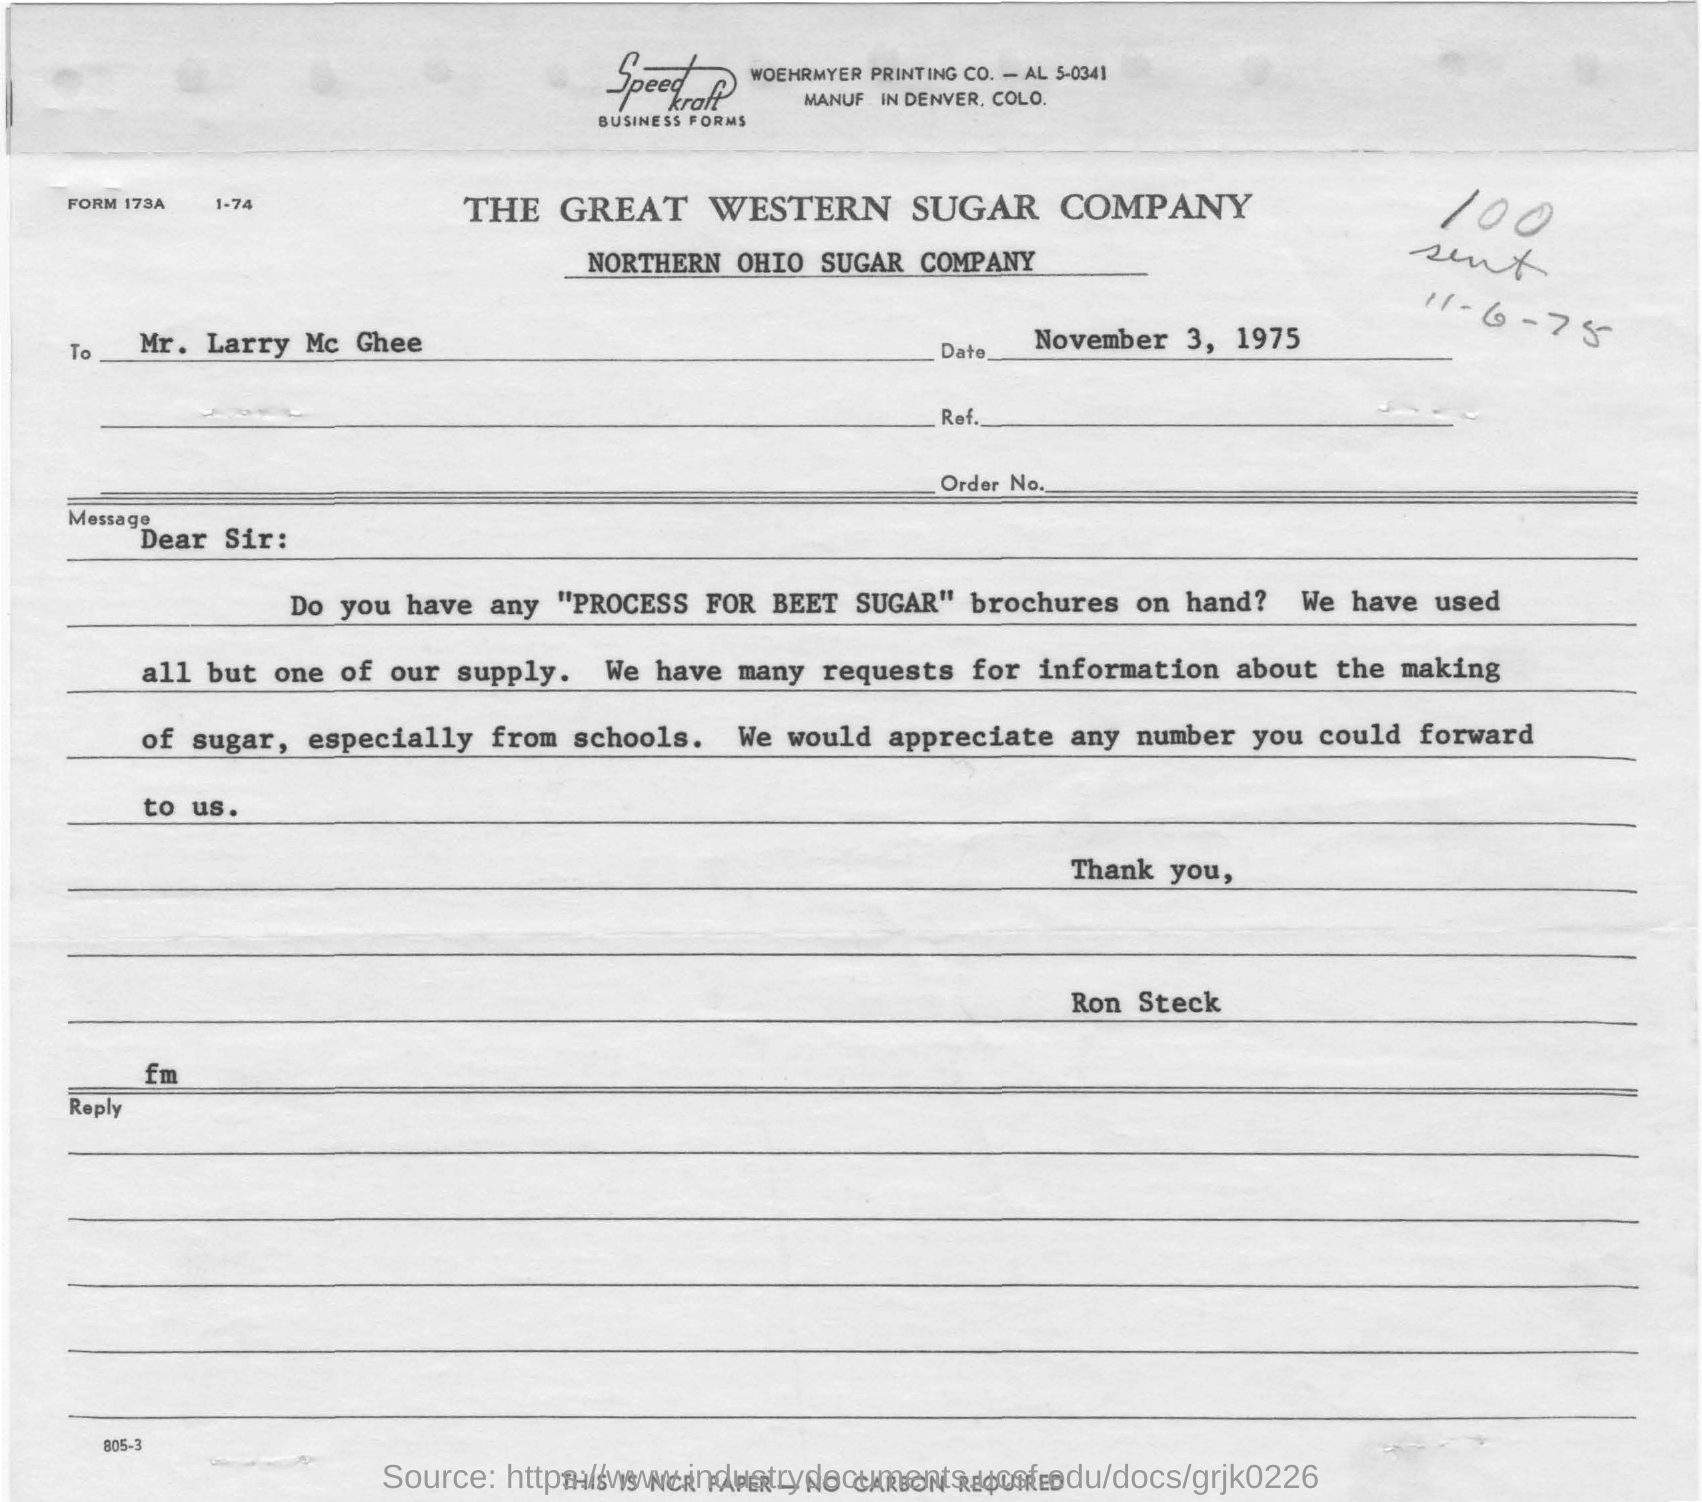Can you infer why the company is specifically receiving requests from schools, as opposed to other organizations or individuals? Schools often seek educational materials to incorporate into their teaching plans, particularly for subjects like science and social studies. Brochures like 'PROCESS FOR BEET SUGAR' provide a practical example of real-world applications of scientific concepts. This hands-on, process-focused information can be an invaluable resource for interactive learning experiences, science fairs, and for fostering understanding of local industries. 